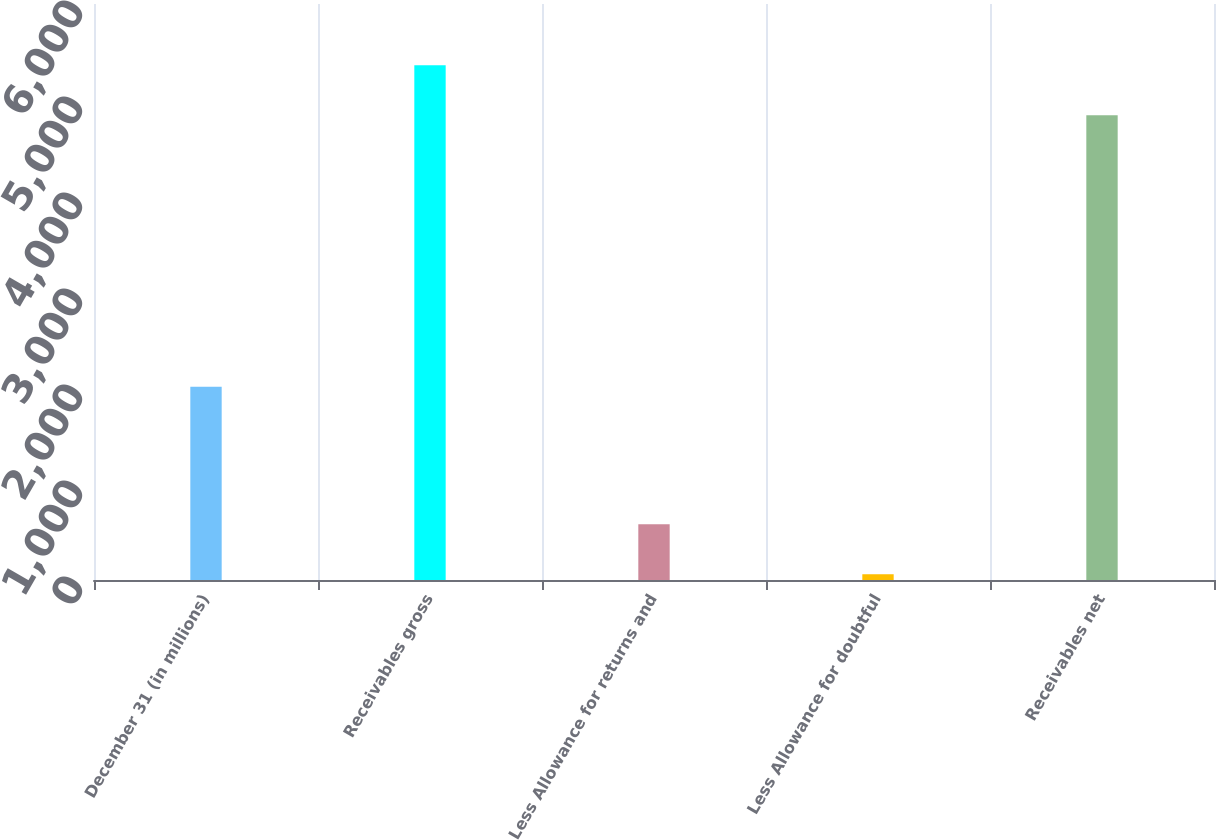<chart> <loc_0><loc_0><loc_500><loc_500><bar_chart><fcel>December 31 (in millions)<fcel>Receivables gross<fcel>Less Allowance for returns and<fcel>Less Allowance for doubtful<fcel>Receivables net<nl><fcel>2014<fcel>5361.8<fcel>579.8<fcel>60<fcel>4842<nl></chart> 